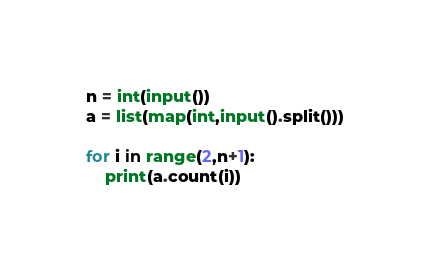Convert code to text. <code><loc_0><loc_0><loc_500><loc_500><_Python_>n = int(input())
a = list(map(int,input().split()))

for i in range(2,n+1):
    print(a.count(i))</code> 